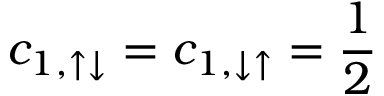Convert formula to latex. <formula><loc_0><loc_0><loc_500><loc_500>c _ { 1 , \uparrow \downarrow } = c _ { 1 , \downarrow \uparrow } = \frac { 1 } { 2 }</formula> 